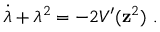<formula> <loc_0><loc_0><loc_500><loc_500>\dot { \lambda } + \lambda ^ { 2 } = - 2 V ^ { \prime } ( { z } ^ { 2 } ) \ .</formula> 